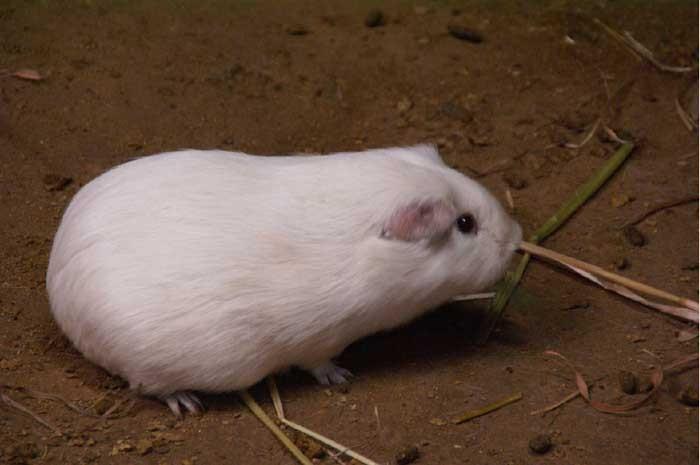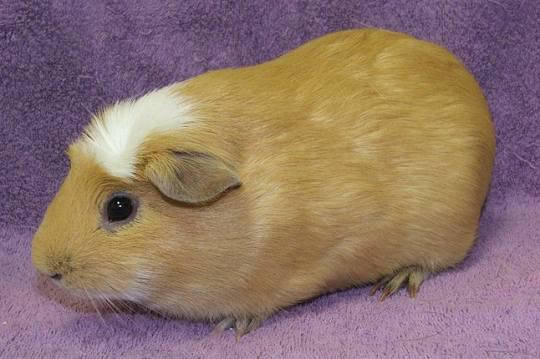The first image is the image on the left, the second image is the image on the right. Evaluate the accuracy of this statement regarding the images: "There are two rodents". Is it true? Answer yes or no. Yes. 